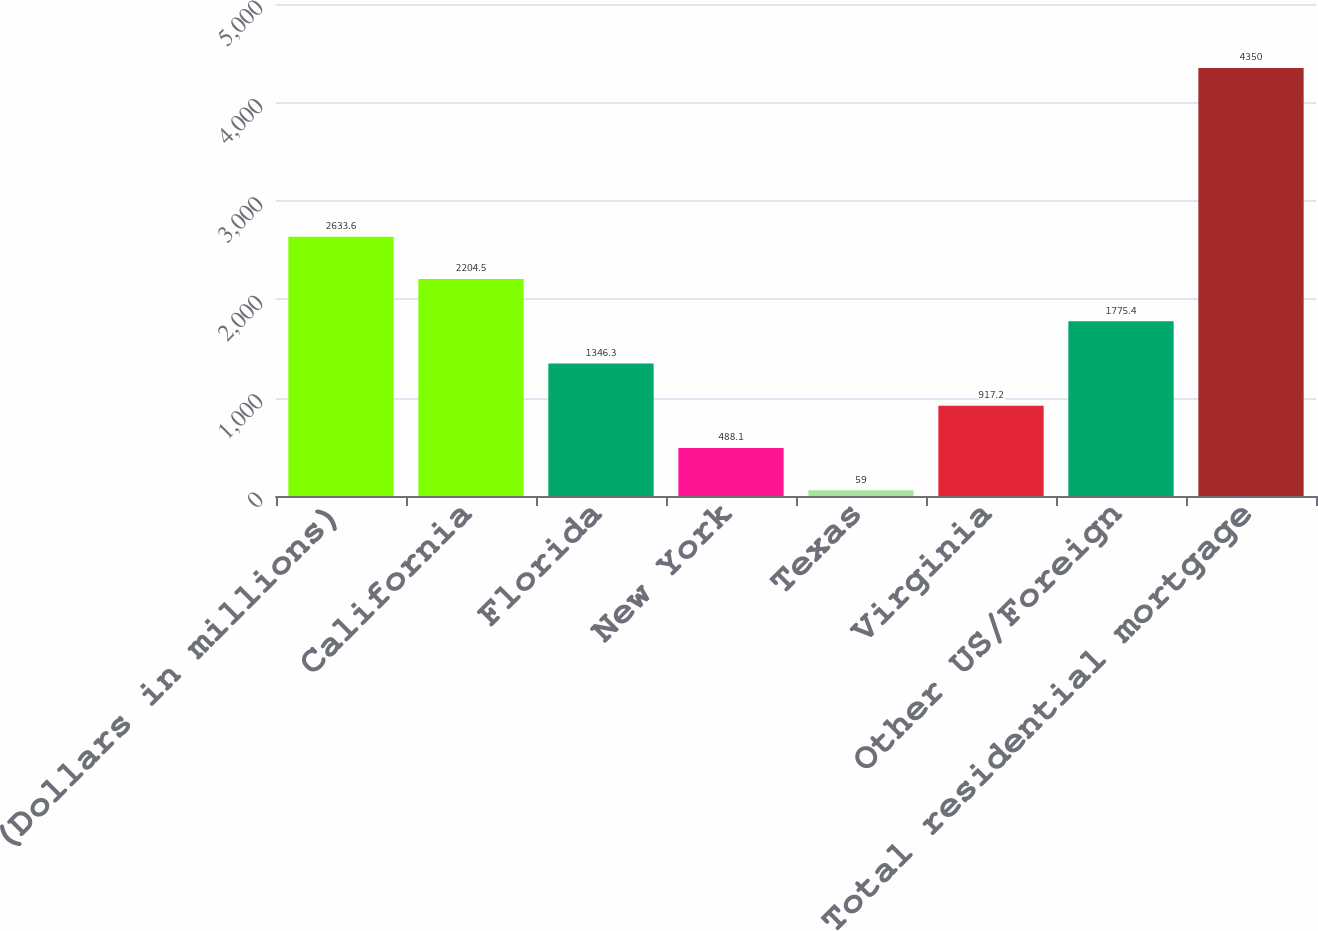<chart> <loc_0><loc_0><loc_500><loc_500><bar_chart><fcel>(Dollars in millions)<fcel>California<fcel>Florida<fcel>New York<fcel>Texas<fcel>Virginia<fcel>Other US/Foreign<fcel>Total residential mortgage<nl><fcel>2633.6<fcel>2204.5<fcel>1346.3<fcel>488.1<fcel>59<fcel>917.2<fcel>1775.4<fcel>4350<nl></chart> 